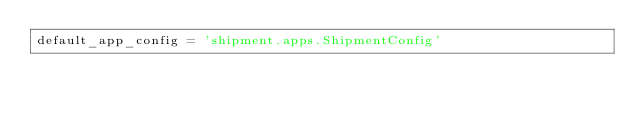<code> <loc_0><loc_0><loc_500><loc_500><_Python_>default_app_config = 'shipment.apps.ShipmentConfig'</code> 